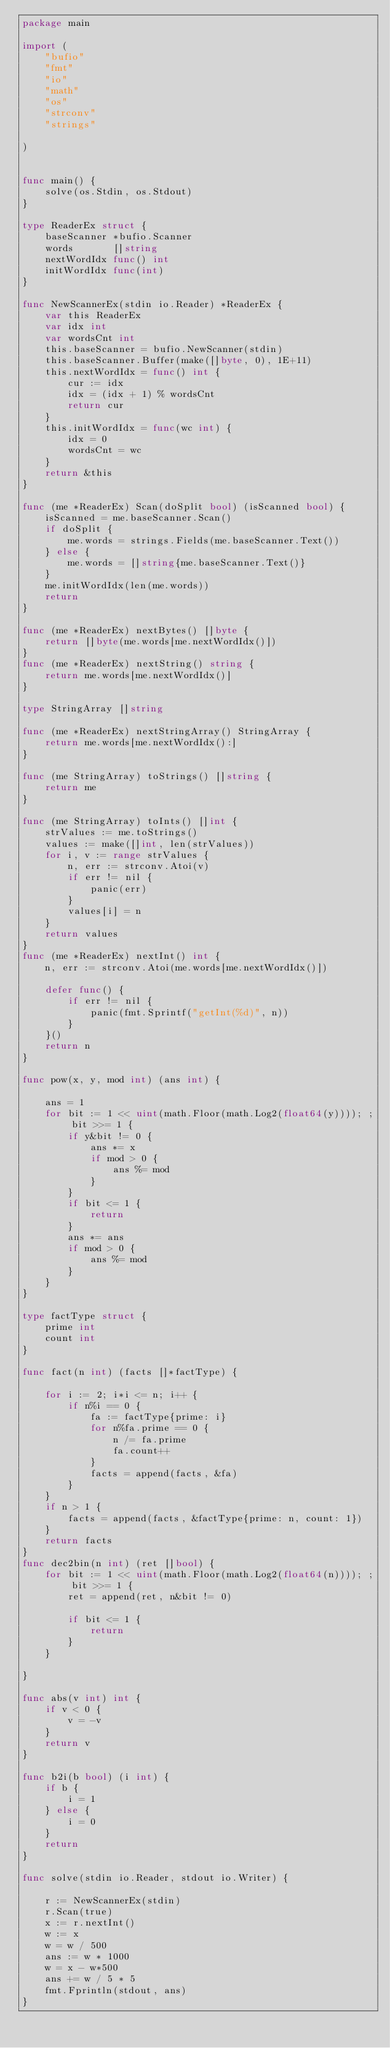Convert code to text. <code><loc_0><loc_0><loc_500><loc_500><_Go_>package main

import (
	"bufio"
	"fmt"
	"io"
	"math"
	"os"
	"strconv"
	"strings"

)


func main() {
	solve(os.Stdin, os.Stdout)
}

type ReaderEx struct {
	baseScanner *bufio.Scanner
	words       []string
	nextWordIdx func() int
	initWordIdx func(int)
}

func NewScannerEx(stdin io.Reader) *ReaderEx {
	var this ReaderEx
	var idx int
	var wordsCnt int
	this.baseScanner = bufio.NewScanner(stdin)
	this.baseScanner.Buffer(make([]byte, 0), 1E+11)
	this.nextWordIdx = func() int {
		cur := idx
		idx = (idx + 1) % wordsCnt
		return cur
	}
	this.initWordIdx = func(wc int) {
		idx = 0
		wordsCnt = wc
	}
	return &this
}

func (me *ReaderEx) Scan(doSplit bool) (isScanned bool) {
	isScanned = me.baseScanner.Scan()
	if doSplit {
		me.words = strings.Fields(me.baseScanner.Text())
	} else {
		me.words = []string{me.baseScanner.Text()}
	}
	me.initWordIdx(len(me.words))
	return
}

func (me *ReaderEx) nextBytes() []byte {
	return []byte(me.words[me.nextWordIdx()])
}
func (me *ReaderEx) nextString() string {
	return me.words[me.nextWordIdx()]
}

type StringArray []string

func (me *ReaderEx) nextStringArray() StringArray {
	return me.words[me.nextWordIdx():]
}

func (me StringArray) toStrings() []string {
	return me
}

func (me StringArray) toInts() []int {
	strValues := me.toStrings()
	values := make([]int, len(strValues))
	for i, v := range strValues {
		n, err := strconv.Atoi(v)
		if err != nil {
			panic(err)
		}
		values[i] = n
	}
	return values
}
func (me *ReaderEx) nextInt() int {
	n, err := strconv.Atoi(me.words[me.nextWordIdx()])

	defer func() {
		if err != nil {
			panic(fmt.Sprintf("getInt(%d)", n))
		}
	}()
	return n
}

func pow(x, y, mod int) (ans int) {

	ans = 1
	for bit := 1 << uint(math.Floor(math.Log2(float64(y)))); ; bit >>= 1 {
		if y&bit != 0 {
			ans *= x
			if mod > 0 {
				ans %= mod
			}
		}
		if bit <= 1 {
			return
		}
		ans *= ans
		if mod > 0 {
			ans %= mod
		}
	}
}

type factType struct {
	prime int
	count int
}

func fact(n int) (facts []*factType) {

	for i := 2; i*i <= n; i++ {
		if n%i == 0 {
			fa := factType{prime: i}
			for n%fa.prime == 0 {
				n /= fa.prime
				fa.count++
			}
			facts = append(facts, &fa)
		}
	}
	if n > 1 {
		facts = append(facts, &factType{prime: n, count: 1})
	}
	return facts
}
func dec2bin(n int) (ret []bool) {
	for bit := 1 << uint(math.Floor(math.Log2(float64(n)))); ; bit >>= 1 {
		ret = append(ret, n&bit != 0)

		if bit <= 1 {
			return
		}
	}

}

func abs(v int) int {
	if v < 0 {
		v = -v
	}
	return v
}

func b2i(b bool) (i int) {
	if b {
		i = 1
	} else {
		i = 0
	}
	return
}

func solve(stdin io.Reader, stdout io.Writer) {

	r := NewScannerEx(stdin)
	r.Scan(true)
	x := r.nextInt()
	w := x
	w = w / 500
	ans := w * 1000
	w = x - w*500
	ans += w / 5 * 5
	fmt.Fprintln(stdout, ans)
}
</code> 